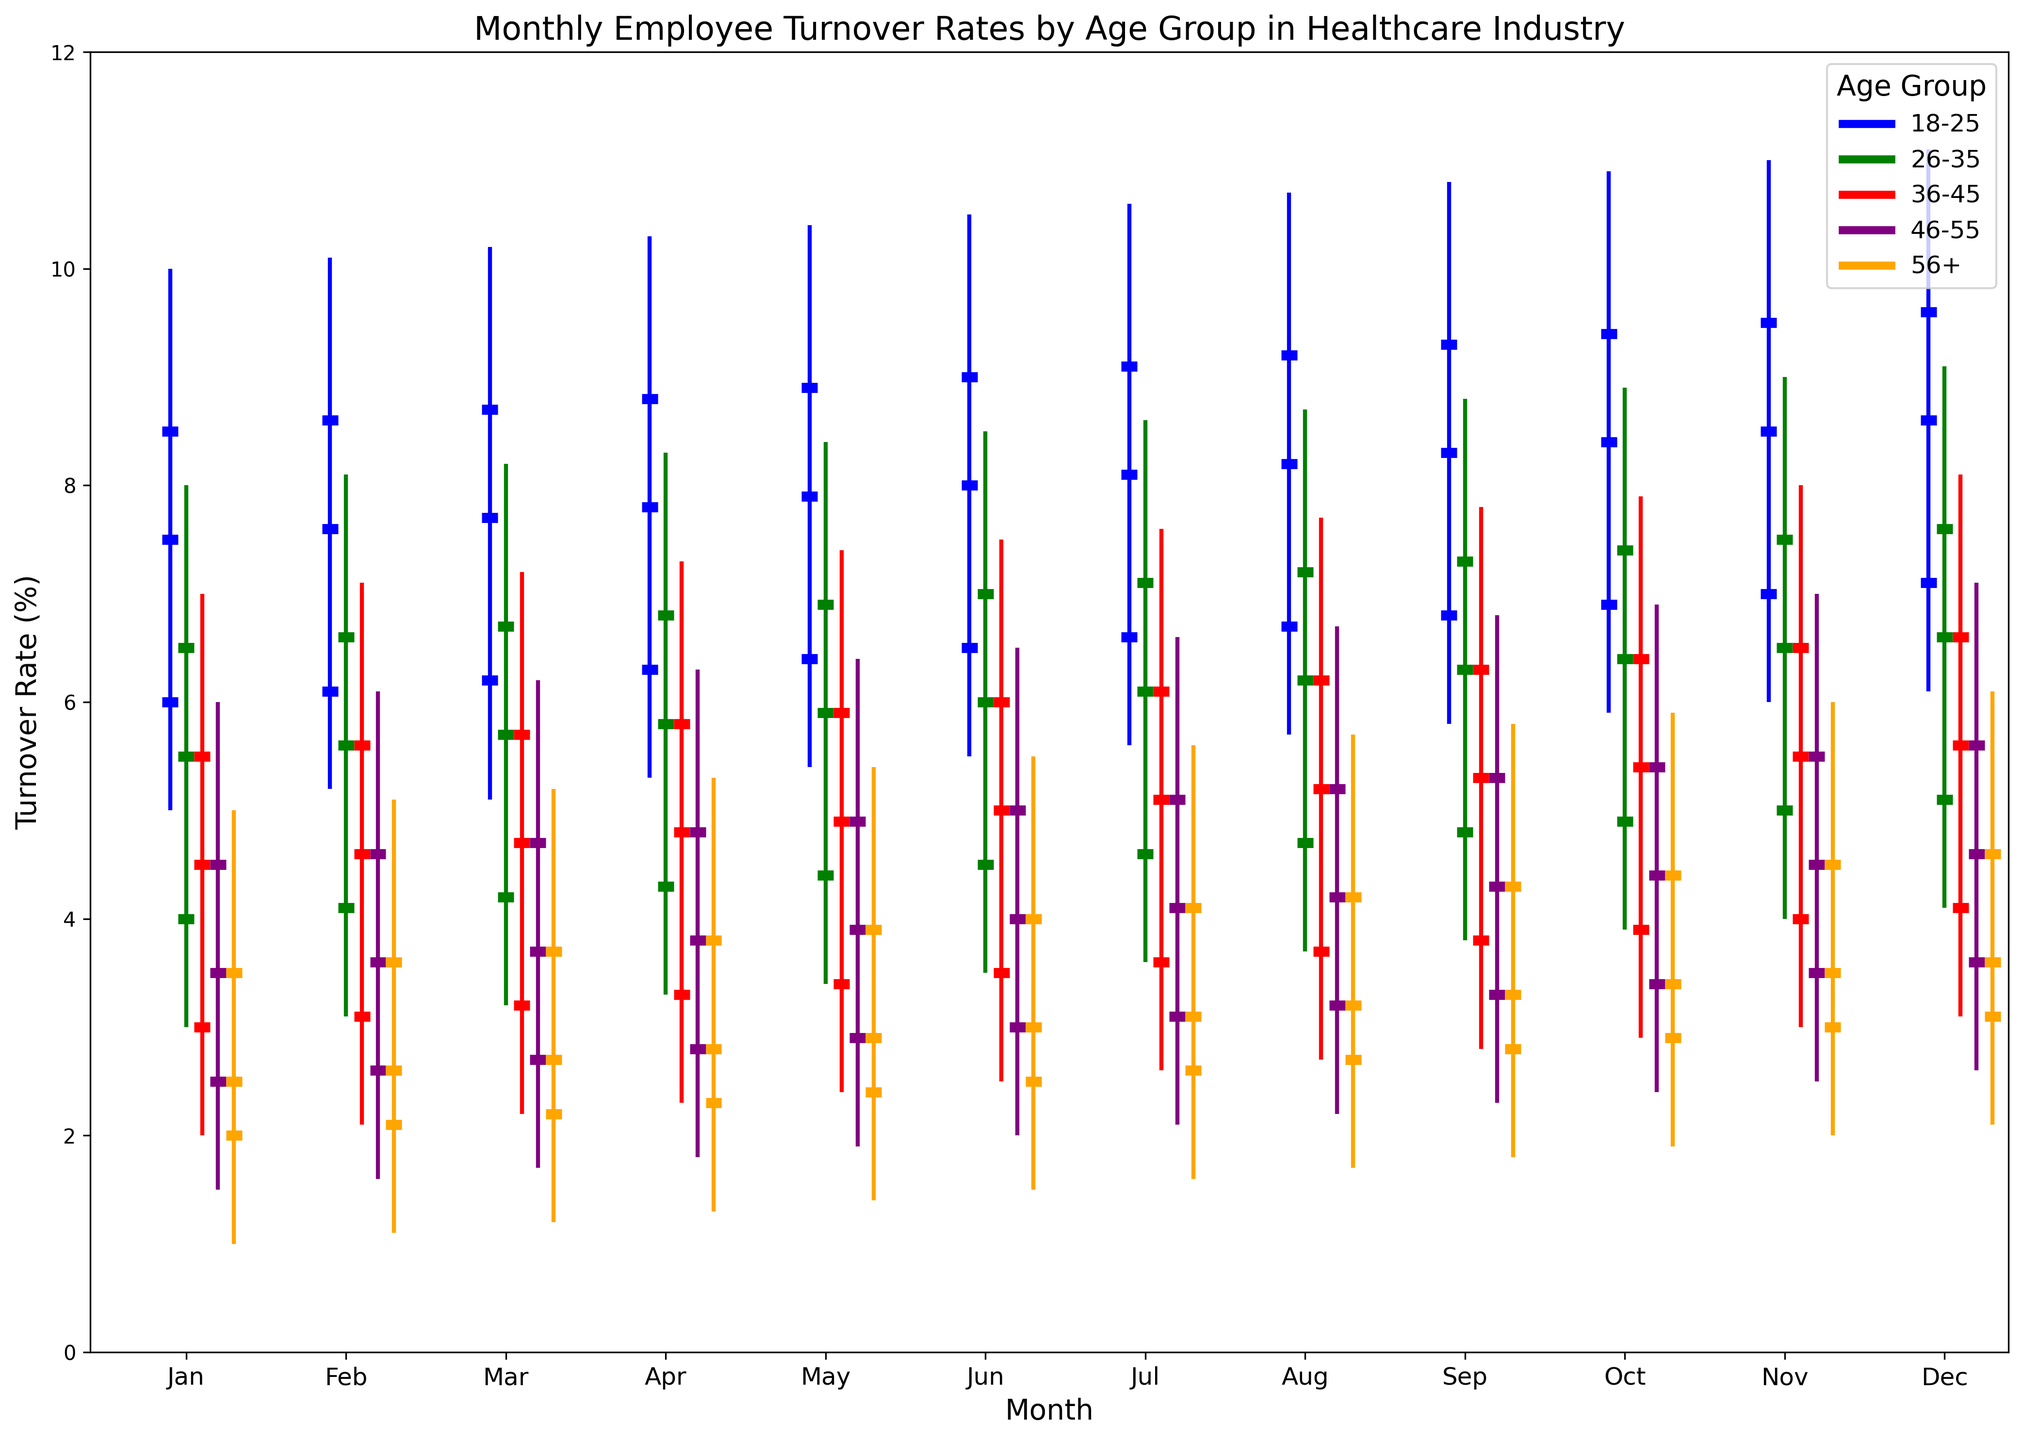What is the highest turnover rate for the 18-25 age group in June? Look at the candlestick corresponding to the 18-25 age group in June, identify the highest point on the vertical line.
Answer: 10.5% Which age group has the lowest median turnover rate in February? Compare the median turnover rate across all age groups in February by looking at the middle horizontal bar of each candlestick. The 56+ age group has the lowest median turnover rate.
Answer: 56+ Compare the median turnover rate of the 26-35 age group in April and May. Which month has a higher rate? Locate the candlesticks for the 26-35 age group in April and May, then compare the positions of the middle horizontal bars.
Answer: May What is the difference between the highest and lowest turnover rates for the 36-45 age group in November? Look at the candlestick for the 36-45 age group in November, observe the endpoints of the vertical line (highest and lowest values) and compute the difference.
Answer: 5.0% For the month of March, which age group has the highest Q3 turnover rate? Compare the Q3 turnover rates (third horizontal bar from the bottom) of each age group in March, and identify the highest one.
Answer: 18-25 What is the average of the median turnover rates for the 46-55 age group over the first three months of the year? Identify the median turnover rates for the 46-55 age group in January, February, and March. Sum these values and divide by 3.
Answer: 3.6% How does the median turnover rate for the 56+ age group change from January to December? Compare the middle horizontal bar positions of the 56+ age group in January and December.
Answer: Increases Which month shows the widest range (difference between max and min) in turnover rates for the 26-35 age group? Compare the range between the highest and lowest points of the vertical lines of the 26-35 age group for each month and identify the widest.
Answer: November By how much does the maximum turnover rate for the 18-25 age group change from August to October? Subtract the maximum turnover rate in August from that in October for the 18-25 age group.
Answer: 0.2% 